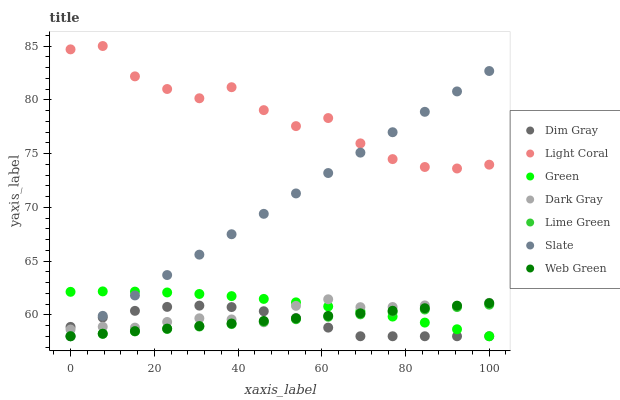Does Dim Gray have the minimum area under the curve?
Answer yes or no. Yes. Does Light Coral have the maximum area under the curve?
Answer yes or no. Yes. Does Slate have the minimum area under the curve?
Answer yes or no. No. Does Slate have the maximum area under the curve?
Answer yes or no. No. Is Lime Green the smoothest?
Answer yes or no. Yes. Is Light Coral the roughest?
Answer yes or no. Yes. Is Dim Gray the smoothest?
Answer yes or no. No. Is Dim Gray the roughest?
Answer yes or no. No. Does Dim Gray have the lowest value?
Answer yes or no. Yes. Does Light Coral have the lowest value?
Answer yes or no. No. Does Light Coral have the highest value?
Answer yes or no. Yes. Does Slate have the highest value?
Answer yes or no. No. Is Green less than Light Coral?
Answer yes or no. Yes. Is Light Coral greater than Web Green?
Answer yes or no. Yes. Does Lime Green intersect Web Green?
Answer yes or no. Yes. Is Lime Green less than Web Green?
Answer yes or no. No. Is Lime Green greater than Web Green?
Answer yes or no. No. Does Green intersect Light Coral?
Answer yes or no. No. 